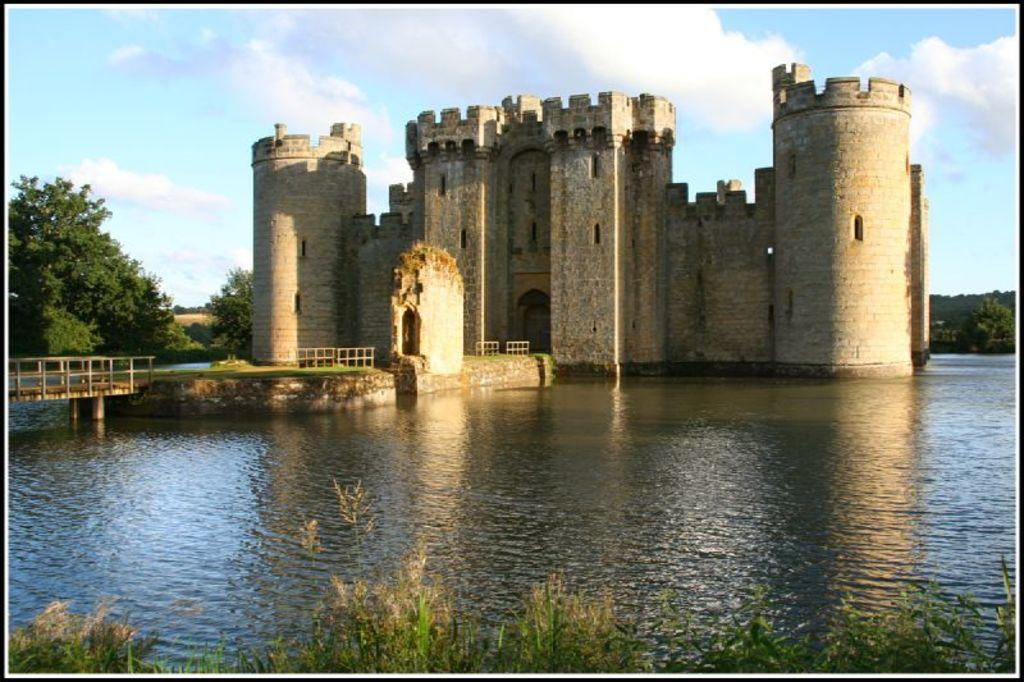What is the primary element in the image? The primary element in the image is water. What type of structure can be seen in the image? Ancient architecture is depicted in the image. What type of vegetation is present in the image? Trees and grass are visible in the image. What is the condition of the sky in the image? The sky is visible in the background of the image, and clouds are present. What is the purpose of the fence in the image? The purpose of the fence in the image is not specified, but it could be for enclosing an area or providing a boundary. What type of disease is affecting the quince tree in the image? There is no quince tree or disease present in the image. 